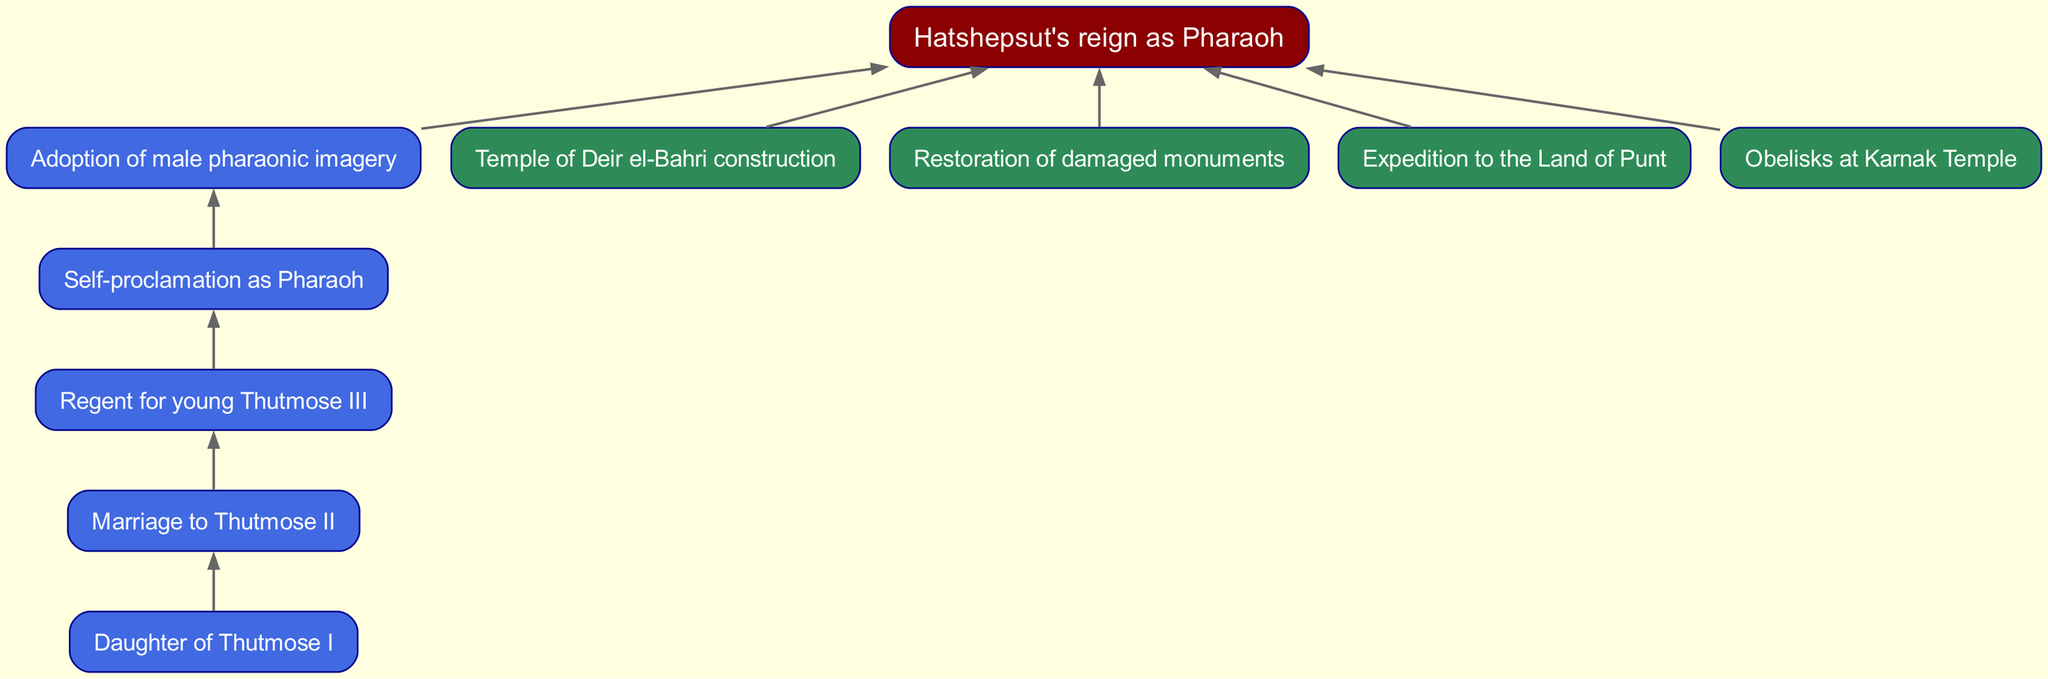What is Hatshepsut's royal lineage? Hatshepsut is the daughter of Thutmose I, married to Thutmose II, and became regent for Thutmose III. This establishes her royal lineage and connection to the throne.
Answer: Daughter of Thutmose I Which node represents Hatshepsut's self-proclamation as Pharaoh? The diagram shows there is a specific node labeled "Self-proclamation as Pharaoh," indicating this was a key moment in her rise to power.
Answer: Self-proclamation as Pharaoh How many architectural projects are detailed in the diagram? The diagram lists four architectural projects, which are the Temple of Deir el-Bahri construction, restoration of damaged monuments, an expedition to the Land of Punt, and obelisks at Karnak Temple.
Answer: 4 What is the sequential order from regent to Pharaoh? The flow indicates that Hatshepsut first served as regent for Thutmose III and then self-proclaimed herself as Pharaoh; the order is therefore Regent, then Pharaoh.
Answer: Regent, then Pharaoh What is the relationship between Hatshepsut and Thutmose III? The diagram indicates that Hatshepsut was regent for the young Thutmose III, showing a governance relationship during his minority.
Answer: Regent for Thutmose III Which architectural project is associated with the construction of the Temple of Deir el-Bahri? The diagram connects the construction of the Temple of Deir el-Bahri to Hatshepsut's reign as Pharaoh, showing it as one of her significant achievements.
Answer: Temple of Deir el-Bahri construction What element signifies Hatshepsut's adoption of male pharaonic imagery? The diagram directly points out the node labeled "Adoption of male pharaonic imagery," which signifies her strategic decision to establish legitimacy.
Answer: Adoption of male pharaonic imagery Which connection denotes Hatshepsut's architectural achievements during her reign? The connections leading into the node representing Hatshepsut's reign as Pharaoh show the architectural projects, highlighting her contributions.
Answer: Architectural projects leading to her reign How many direct lines connect to the main node representing Hatshepsut's reign? The main node has five direct lines connecting it to various events and achievements, signifying multiple aspects of her powerful reign.
Answer: 5 